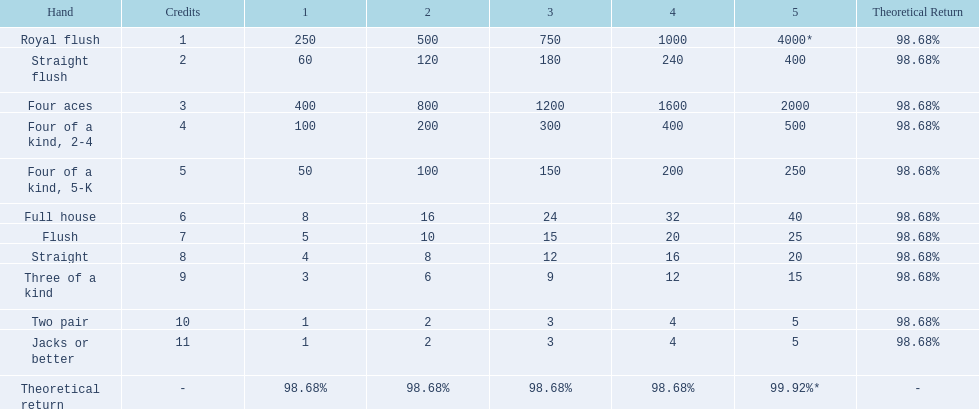What are the hands? Royal flush, Straight flush, Four aces, Four of a kind, 2-4, Four of a kind, 5-K, Full house, Flush, Straight, Three of a kind, Two pair, Jacks or better. Which hand is on the top? Royal flush. 